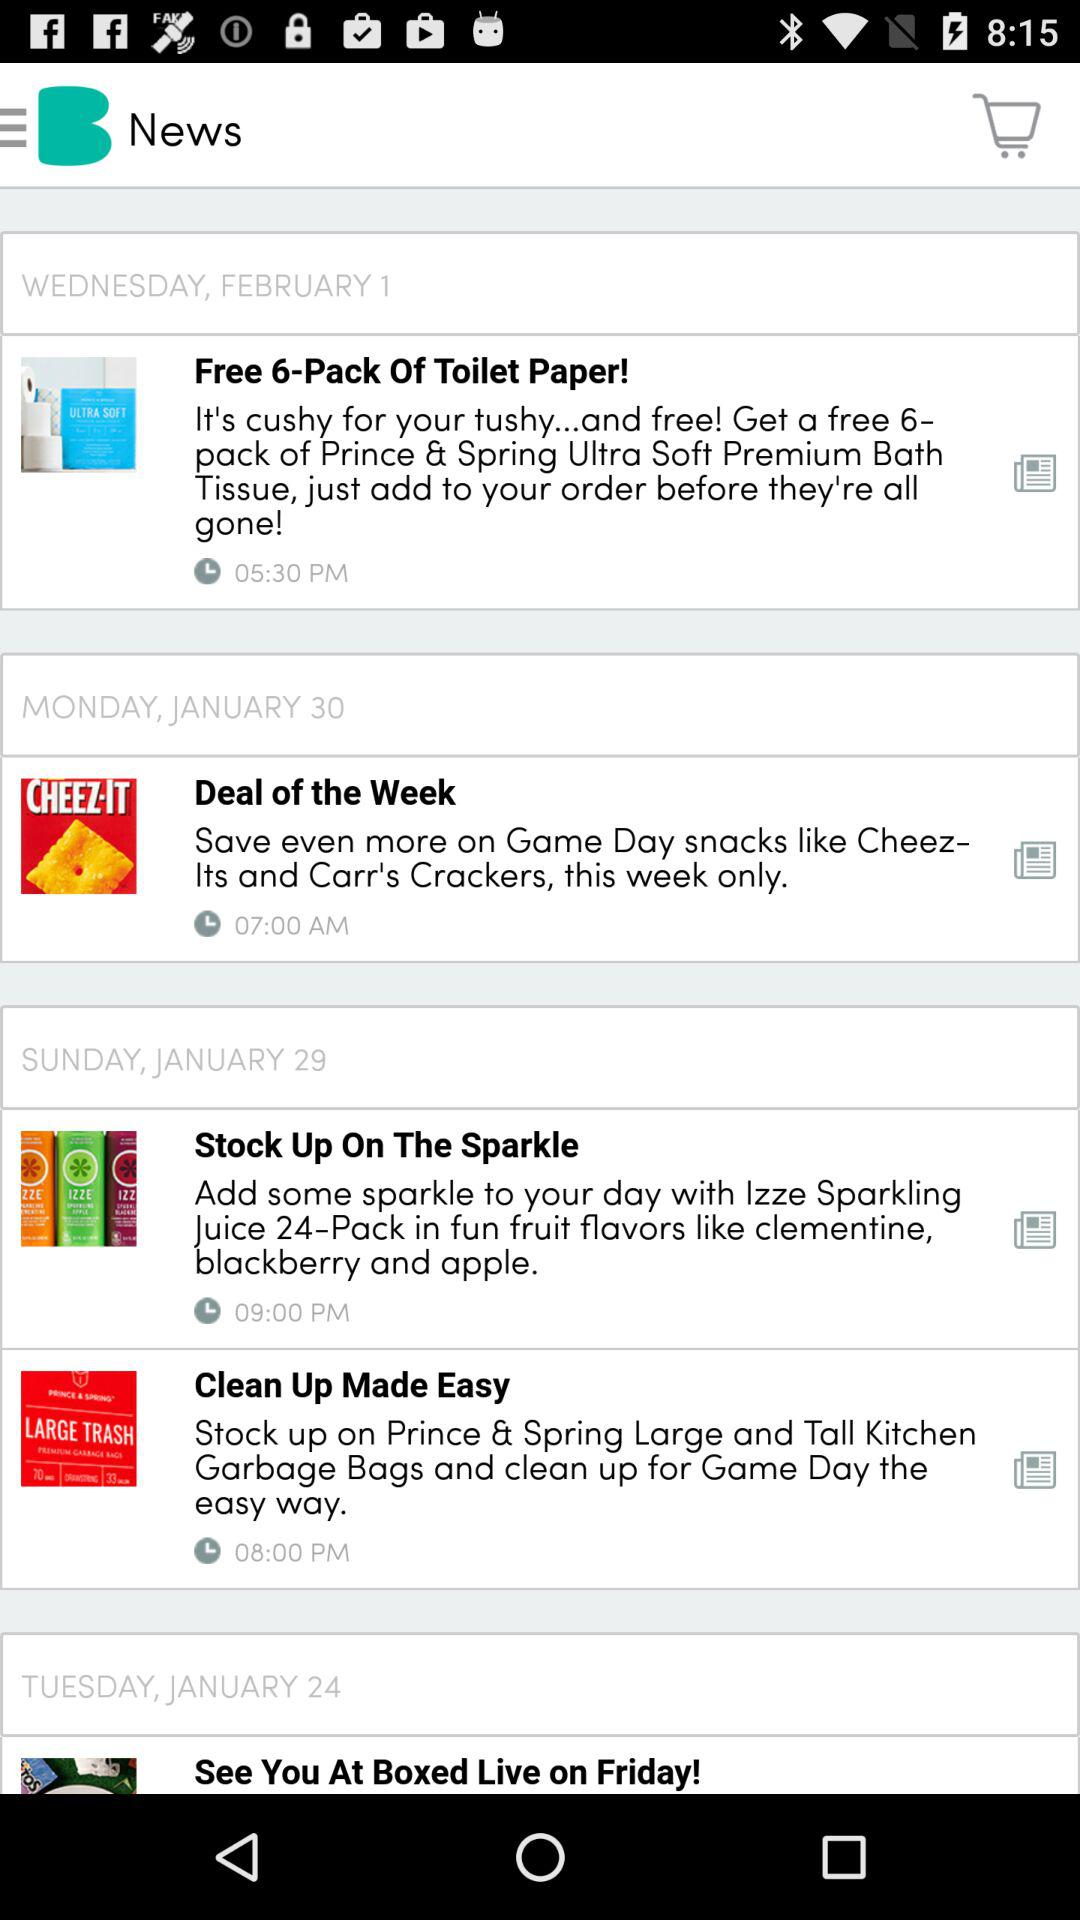What is the date of the news clean up made easy? The date is Sunday, January 29. 